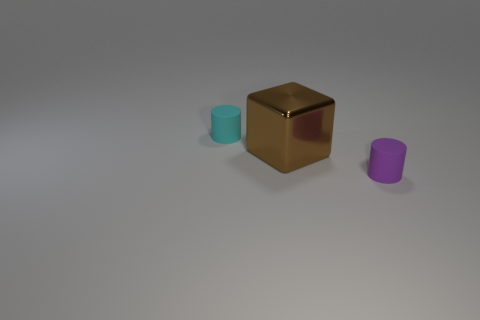What is the approximate size relationship between the objects? The cube appears to be the largest object in terms of volume. The cyan cylinder looks to be the second largest, although it's narrower than the cube. The purple cylinder is not only the smallest in height but also in diameter when compared to the other two objects. 